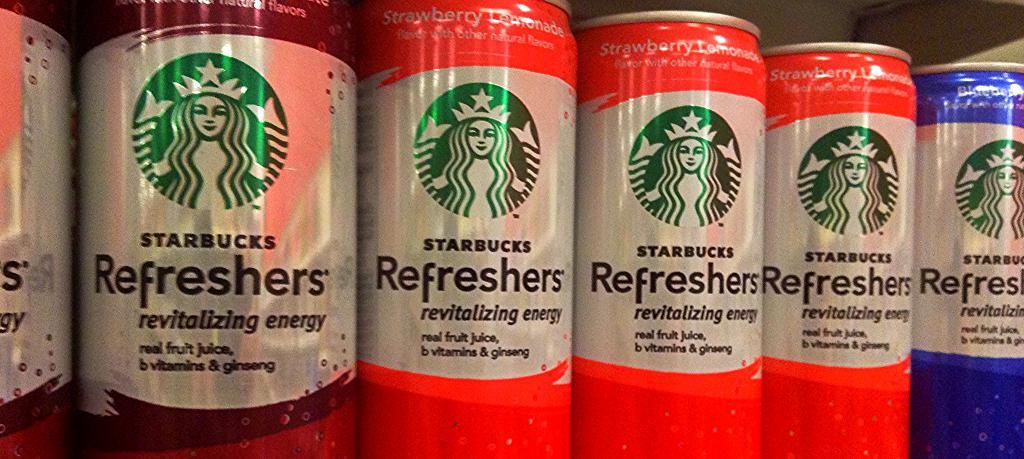<image>
Summarize the visual content of the image. Many cans of Starbucks Refreshers are lined up in a row. 